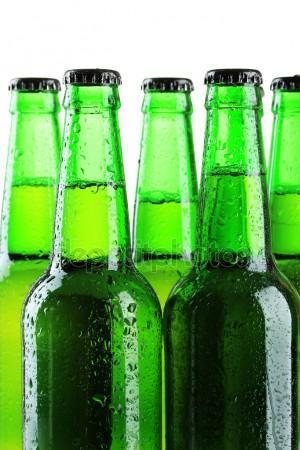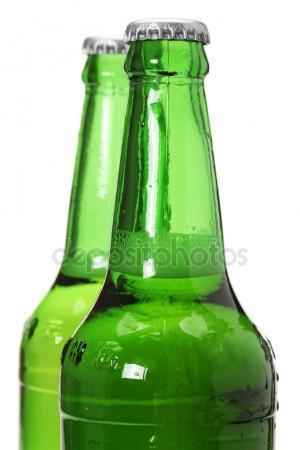The first image is the image on the left, the second image is the image on the right. Evaluate the accuracy of this statement regarding the images: "All the bottles are full.". Is it true? Answer yes or no. Yes. The first image is the image on the left, the second image is the image on the right. Analyze the images presented: Is the assertion "One image contains a diagonal row of three overlapping green bottles with liquid inside and caps on." valid? Answer yes or no. No. 